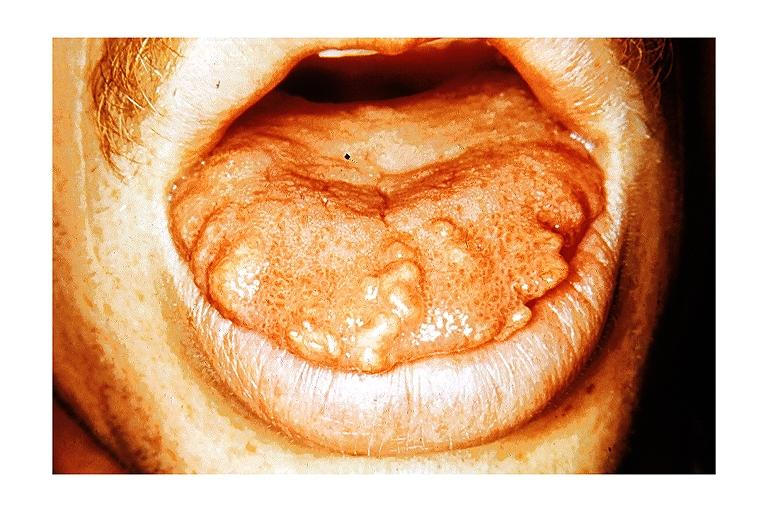what does this image show?
Answer the question using a single word or phrase. Multiple endocrine neoplasia type iib-macroglossia 